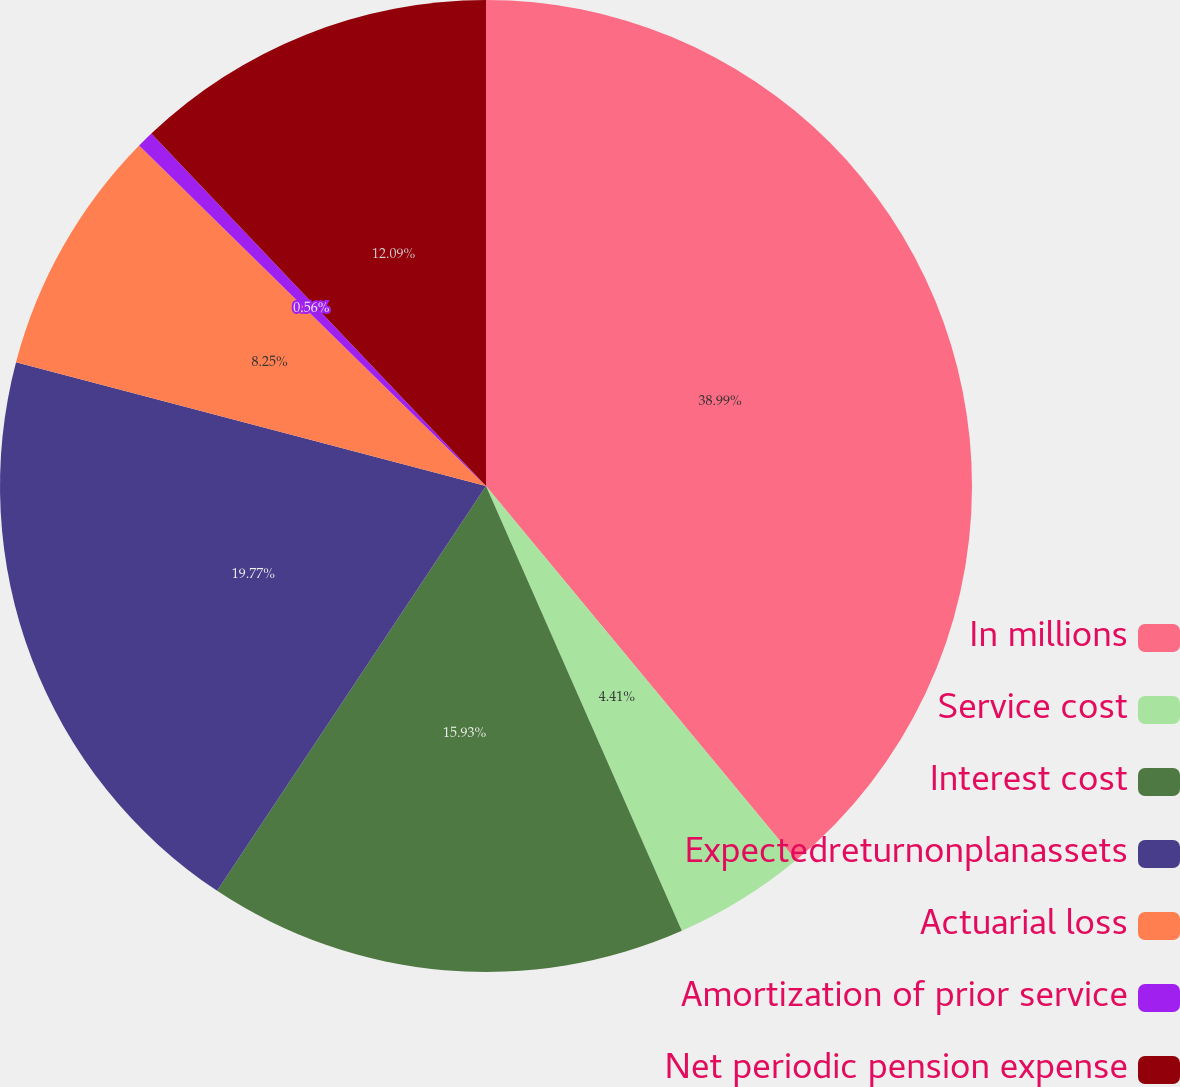<chart> <loc_0><loc_0><loc_500><loc_500><pie_chart><fcel>In millions<fcel>Service cost<fcel>Interest cost<fcel>Expectedreturnonplanassets<fcel>Actuarial loss<fcel>Amortization of prior service<fcel>Net periodic pension expense<nl><fcel>38.99%<fcel>4.41%<fcel>15.93%<fcel>19.77%<fcel>8.25%<fcel>0.56%<fcel>12.09%<nl></chart> 